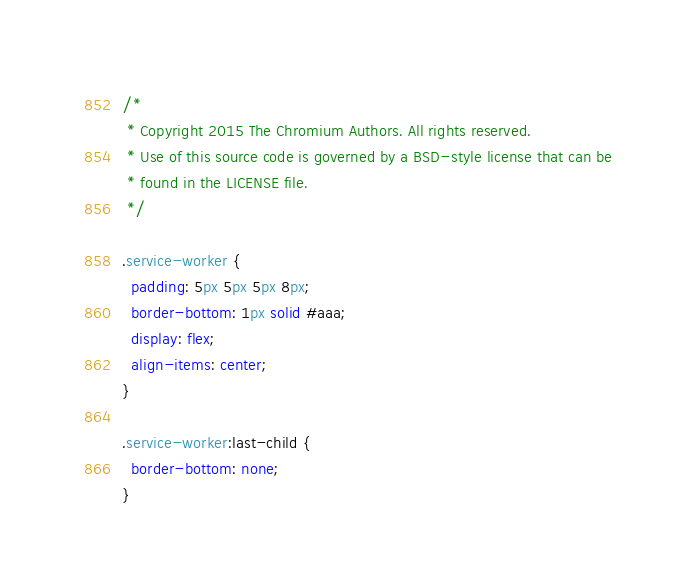<code> <loc_0><loc_0><loc_500><loc_500><_CSS_>/*
 * Copyright 2015 The Chromium Authors. All rights reserved.
 * Use of this source code is governed by a BSD-style license that can be
 * found in the LICENSE file.
 */

.service-worker {
  padding: 5px 5px 5px 8px;
  border-bottom: 1px solid #aaa;
  display: flex;
  align-items: center;
}

.service-worker:last-child {
  border-bottom: none;
}
</code> 